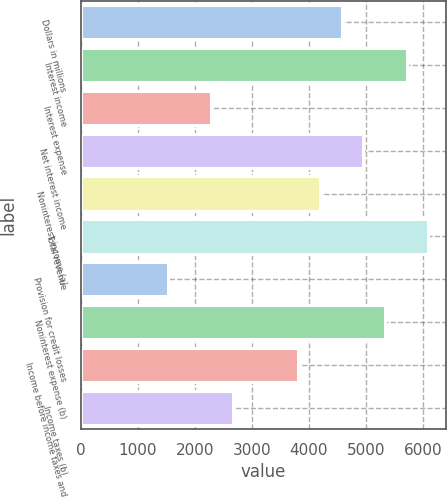<chart> <loc_0><loc_0><loc_500><loc_500><bar_chart><fcel>Dollars in millions<fcel>Interest income<fcel>Interest expense<fcel>Net interest income<fcel>Noninterest income (a)<fcel>Total revenue<fcel>Provision for credit losses<fcel>Noninterest expense (b)<fcel>Income before income taxes and<fcel>Income taxes (b)<nl><fcel>4571.62<fcel>5714.07<fcel>2286.74<fcel>4952.43<fcel>4190.81<fcel>6094.89<fcel>1525.12<fcel>5333.25<fcel>3809.99<fcel>2667.55<nl></chart> 